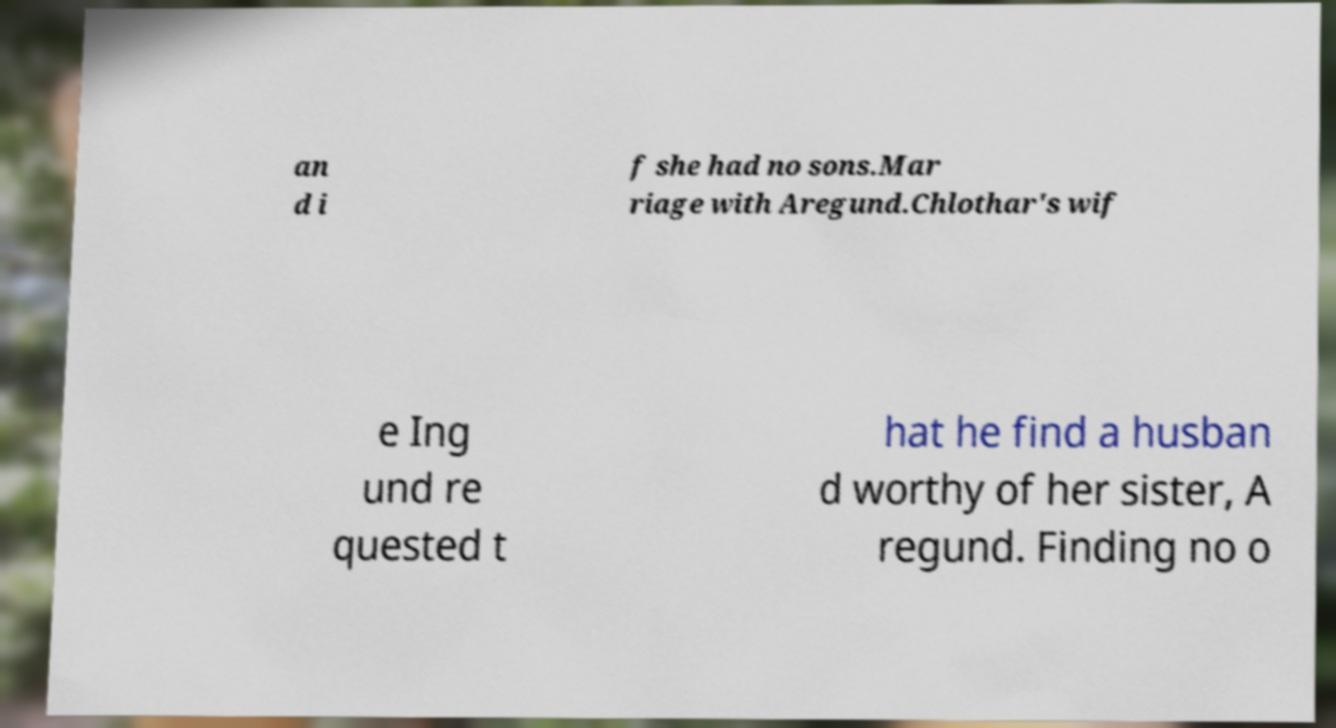For documentation purposes, I need the text within this image transcribed. Could you provide that? an d i f she had no sons.Mar riage with Aregund.Chlothar's wif e Ing und re quested t hat he find a husban d worthy of her sister, A regund. Finding no o 